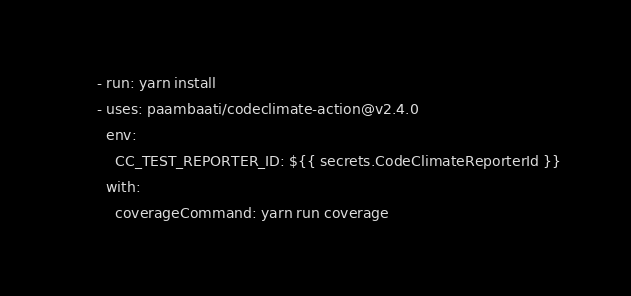<code> <loc_0><loc_0><loc_500><loc_500><_YAML_>      - run: yarn install
      - uses: paambaati/codeclimate-action@v2.4.0
        env:
          CC_TEST_REPORTER_ID: ${{ secrets.CodeClimateReporterId }}
        with:
          coverageCommand: yarn run coverage
</code> 